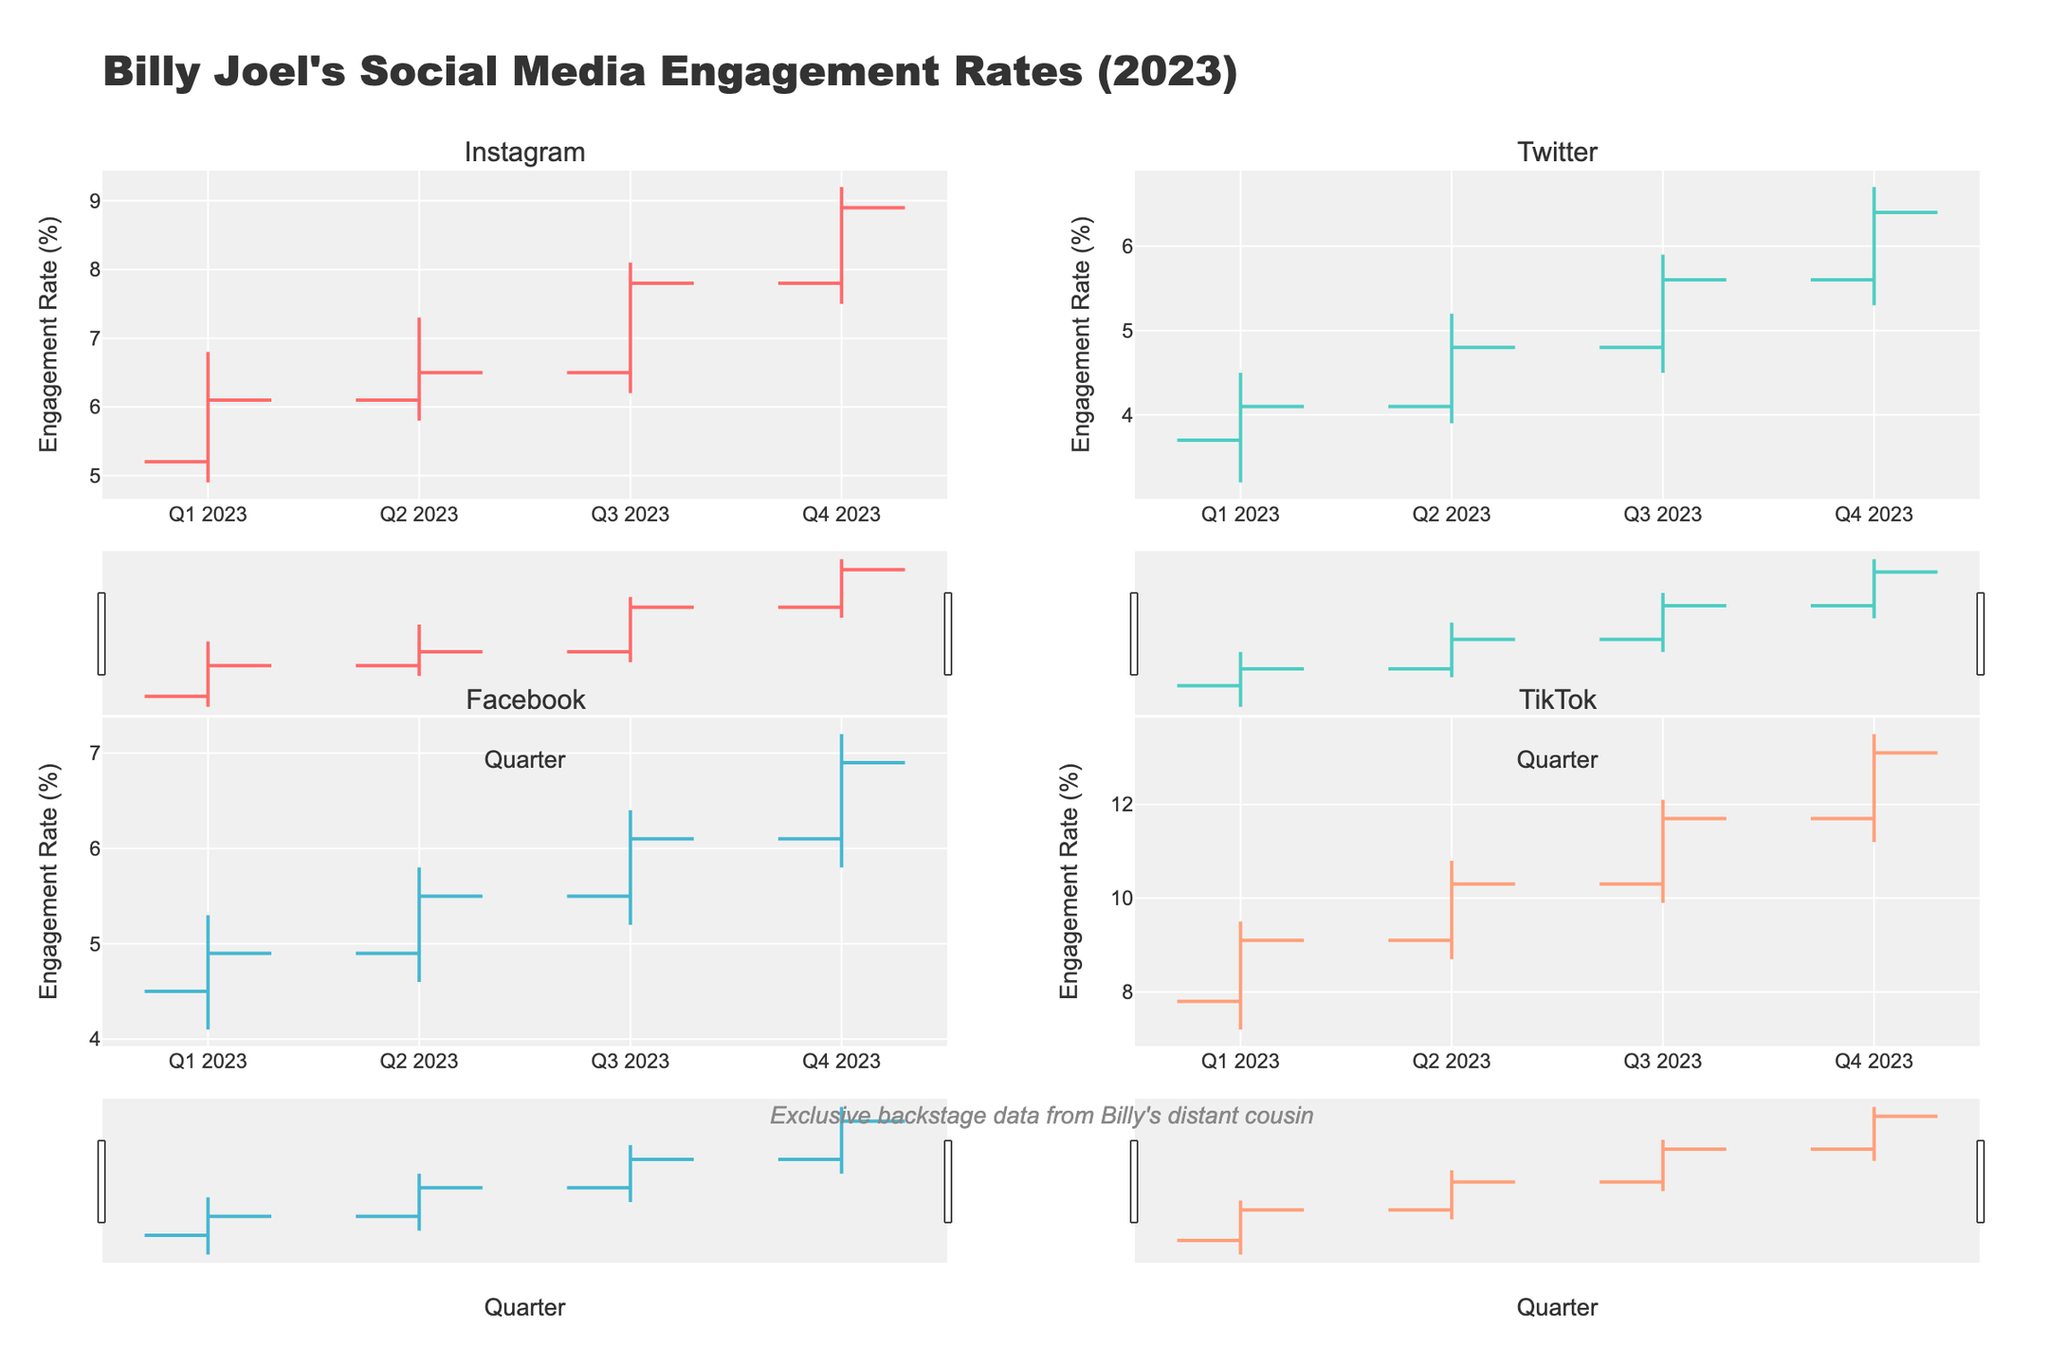What is the title of the figure? The title of the figure can be found at the top, usually larger and bolder than other texts.
Answer: Billy Joel's Social Media Engagement Rates (2023) Which platform had the highest engagement rate in Q4 2023? Locate the Q4 2023 segment on each platform subplot. The highest point within this segment indicates the peak engagement rate.
Answer: TikTok How did Instagram's engagement rate change from Q1 2023 to Q2 2023 in terms of the closing value? Compare the closing values of Instagram for Q1 2023 and Q2 2023: 6.1% (Q1) and 6.5% (Q2).
Answer: Increased By how much did Twitter's engagement rate increase in Q3 2023 from its opening value to its closing value? Subtract the opening value for Q3 2023 (4.8) from the closing value for the same quarter (5.6) for Twitter.
Answer: 0.8 Which platform had the smallest range in engagement rate for Q1 2023? For each platform in Q1 2023, calculate the range (High - Low) and compare them.
Answer: Twitter Between Facebook and Instagram, which showed a larger increase in the highest engagement rate from Q2 2023 to Q3 2023? Calculate the increase in the highest engagement rate for both platforms: Facebook from 5.8% to 6.4% (increase of 0.6), Instagram from 7.3% to 8.1% (increase of 0.8), and compare them.
Answer: Instagram What was the average closing value of TikTok’s engagement rate across all quarters? Sum the closing values of TikTok (9.1, 10.3, 11.7, 13.1) and divide by the number of quarters (4).
Answer: 11.05 Is there a quarter where all platforms experienced an increase in their engagement rate from opening to closing values? If yes, which one? For each quarter, check if the close is greater than the open for all platforms. Q2 2023: Check that all close values are higher than open values.
Answer: Yes, Q2 2023 In Q4 2023, which platform had the engagement rate closest to TikTok’s low value of 11.2? Compare TikTok’s low value (11.2) with the engagement rates of other platforms in Q4 2023 and find the closest match.
Answer: None 